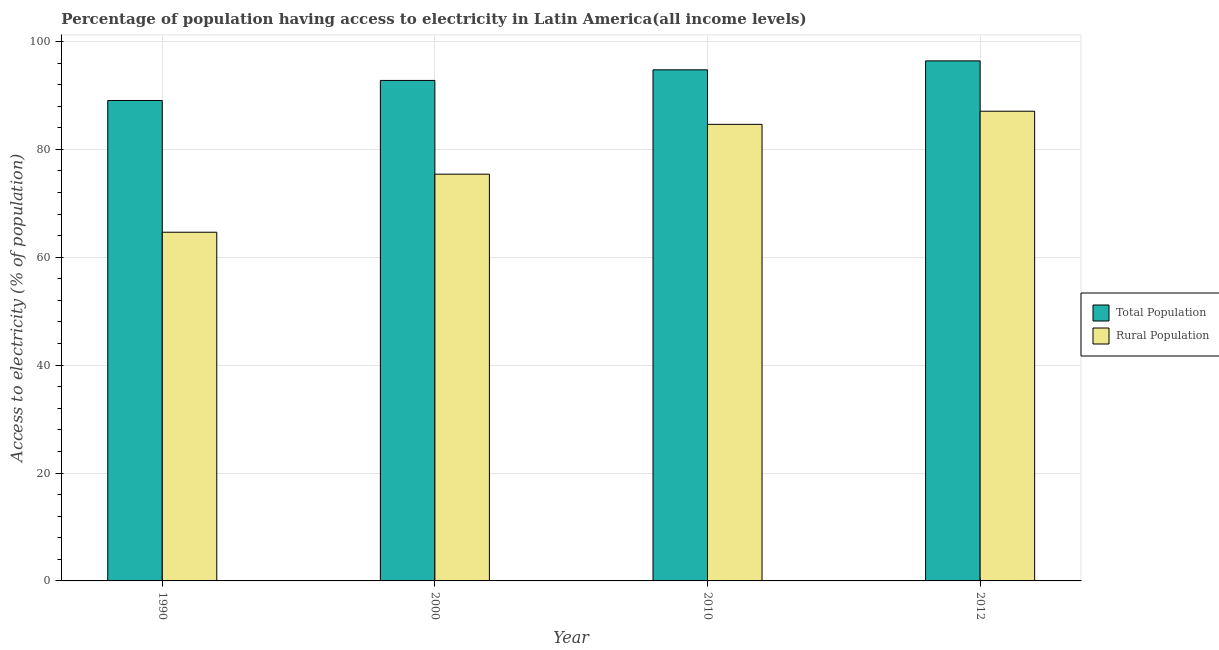How many different coloured bars are there?
Provide a succinct answer. 2. Are the number of bars per tick equal to the number of legend labels?
Give a very brief answer. Yes. How many bars are there on the 4th tick from the right?
Provide a short and direct response. 2. What is the percentage of population having access to electricity in 2000?
Your response must be concise. 92.78. Across all years, what is the maximum percentage of rural population having access to electricity?
Provide a succinct answer. 87.07. Across all years, what is the minimum percentage of population having access to electricity?
Offer a very short reply. 89.06. In which year was the percentage of rural population having access to electricity maximum?
Give a very brief answer. 2012. In which year was the percentage of rural population having access to electricity minimum?
Ensure brevity in your answer.  1990. What is the total percentage of population having access to electricity in the graph?
Your answer should be compact. 373. What is the difference between the percentage of rural population having access to electricity in 2000 and that in 2010?
Give a very brief answer. -9.24. What is the difference between the percentage of rural population having access to electricity in 2012 and the percentage of population having access to electricity in 2010?
Offer a terse response. 2.43. What is the average percentage of rural population having access to electricity per year?
Keep it short and to the point. 77.94. What is the ratio of the percentage of rural population having access to electricity in 2000 to that in 2010?
Your answer should be compact. 0.89. Is the percentage of population having access to electricity in 1990 less than that in 2000?
Offer a very short reply. Yes. Is the difference between the percentage of population having access to electricity in 2000 and 2012 greater than the difference between the percentage of rural population having access to electricity in 2000 and 2012?
Keep it short and to the point. No. What is the difference between the highest and the second highest percentage of rural population having access to electricity?
Offer a very short reply. 2.43. What is the difference between the highest and the lowest percentage of population having access to electricity?
Your answer should be very brief. 7.34. What does the 1st bar from the left in 2010 represents?
Offer a very short reply. Total Population. What does the 1st bar from the right in 2000 represents?
Keep it short and to the point. Rural Population. How many bars are there?
Make the answer very short. 8. Are all the bars in the graph horizontal?
Offer a terse response. No. What is the difference between two consecutive major ticks on the Y-axis?
Provide a succinct answer. 20. Where does the legend appear in the graph?
Offer a very short reply. Center right. How are the legend labels stacked?
Offer a very short reply. Vertical. What is the title of the graph?
Make the answer very short. Percentage of population having access to electricity in Latin America(all income levels). Does "Diesel" appear as one of the legend labels in the graph?
Ensure brevity in your answer.  No. What is the label or title of the Y-axis?
Make the answer very short. Access to electricity (% of population). What is the Access to electricity (% of population) of Total Population in 1990?
Your answer should be very brief. 89.06. What is the Access to electricity (% of population) in Rural Population in 1990?
Offer a very short reply. 64.64. What is the Access to electricity (% of population) of Total Population in 2000?
Offer a terse response. 92.78. What is the Access to electricity (% of population) of Rural Population in 2000?
Your response must be concise. 75.4. What is the Access to electricity (% of population) in Total Population in 2010?
Offer a very short reply. 94.75. What is the Access to electricity (% of population) in Rural Population in 2010?
Ensure brevity in your answer.  84.64. What is the Access to electricity (% of population) in Total Population in 2012?
Your answer should be compact. 96.41. What is the Access to electricity (% of population) of Rural Population in 2012?
Give a very brief answer. 87.07. Across all years, what is the maximum Access to electricity (% of population) in Total Population?
Provide a succinct answer. 96.41. Across all years, what is the maximum Access to electricity (% of population) of Rural Population?
Keep it short and to the point. 87.07. Across all years, what is the minimum Access to electricity (% of population) of Total Population?
Offer a terse response. 89.06. Across all years, what is the minimum Access to electricity (% of population) of Rural Population?
Provide a succinct answer. 64.64. What is the total Access to electricity (% of population) of Total Population in the graph?
Provide a short and direct response. 373. What is the total Access to electricity (% of population) in Rural Population in the graph?
Make the answer very short. 311.76. What is the difference between the Access to electricity (% of population) in Total Population in 1990 and that in 2000?
Provide a succinct answer. -3.72. What is the difference between the Access to electricity (% of population) in Rural Population in 1990 and that in 2000?
Offer a very short reply. -10.76. What is the difference between the Access to electricity (% of population) in Total Population in 1990 and that in 2010?
Provide a short and direct response. -5.68. What is the difference between the Access to electricity (% of population) of Rural Population in 1990 and that in 2010?
Provide a short and direct response. -20. What is the difference between the Access to electricity (% of population) of Total Population in 1990 and that in 2012?
Your answer should be very brief. -7.34. What is the difference between the Access to electricity (% of population) in Rural Population in 1990 and that in 2012?
Your answer should be compact. -22.43. What is the difference between the Access to electricity (% of population) of Total Population in 2000 and that in 2010?
Offer a terse response. -1.96. What is the difference between the Access to electricity (% of population) in Rural Population in 2000 and that in 2010?
Offer a very short reply. -9.24. What is the difference between the Access to electricity (% of population) of Total Population in 2000 and that in 2012?
Offer a terse response. -3.62. What is the difference between the Access to electricity (% of population) of Rural Population in 2000 and that in 2012?
Provide a short and direct response. -11.67. What is the difference between the Access to electricity (% of population) of Total Population in 2010 and that in 2012?
Your answer should be very brief. -1.66. What is the difference between the Access to electricity (% of population) of Rural Population in 2010 and that in 2012?
Your response must be concise. -2.43. What is the difference between the Access to electricity (% of population) in Total Population in 1990 and the Access to electricity (% of population) in Rural Population in 2000?
Offer a very short reply. 13.66. What is the difference between the Access to electricity (% of population) of Total Population in 1990 and the Access to electricity (% of population) of Rural Population in 2010?
Keep it short and to the point. 4.42. What is the difference between the Access to electricity (% of population) of Total Population in 1990 and the Access to electricity (% of population) of Rural Population in 2012?
Provide a short and direct response. 1.99. What is the difference between the Access to electricity (% of population) of Total Population in 2000 and the Access to electricity (% of population) of Rural Population in 2010?
Provide a succinct answer. 8.14. What is the difference between the Access to electricity (% of population) of Total Population in 2000 and the Access to electricity (% of population) of Rural Population in 2012?
Your response must be concise. 5.71. What is the difference between the Access to electricity (% of population) of Total Population in 2010 and the Access to electricity (% of population) of Rural Population in 2012?
Provide a succinct answer. 7.67. What is the average Access to electricity (% of population) in Total Population per year?
Provide a succinct answer. 93.25. What is the average Access to electricity (% of population) in Rural Population per year?
Offer a terse response. 77.94. In the year 1990, what is the difference between the Access to electricity (% of population) of Total Population and Access to electricity (% of population) of Rural Population?
Make the answer very short. 24.42. In the year 2000, what is the difference between the Access to electricity (% of population) of Total Population and Access to electricity (% of population) of Rural Population?
Your response must be concise. 17.38. In the year 2010, what is the difference between the Access to electricity (% of population) in Total Population and Access to electricity (% of population) in Rural Population?
Provide a succinct answer. 10.1. In the year 2012, what is the difference between the Access to electricity (% of population) of Total Population and Access to electricity (% of population) of Rural Population?
Provide a short and direct response. 9.33. What is the ratio of the Access to electricity (% of population) in Total Population in 1990 to that in 2000?
Provide a short and direct response. 0.96. What is the ratio of the Access to electricity (% of population) in Rural Population in 1990 to that in 2000?
Keep it short and to the point. 0.86. What is the ratio of the Access to electricity (% of population) in Rural Population in 1990 to that in 2010?
Your answer should be compact. 0.76. What is the ratio of the Access to electricity (% of population) in Total Population in 1990 to that in 2012?
Your answer should be very brief. 0.92. What is the ratio of the Access to electricity (% of population) in Rural Population in 1990 to that in 2012?
Your answer should be very brief. 0.74. What is the ratio of the Access to electricity (% of population) in Total Population in 2000 to that in 2010?
Offer a very short reply. 0.98. What is the ratio of the Access to electricity (% of population) in Rural Population in 2000 to that in 2010?
Provide a succinct answer. 0.89. What is the ratio of the Access to electricity (% of population) of Total Population in 2000 to that in 2012?
Offer a terse response. 0.96. What is the ratio of the Access to electricity (% of population) in Rural Population in 2000 to that in 2012?
Keep it short and to the point. 0.87. What is the ratio of the Access to electricity (% of population) in Total Population in 2010 to that in 2012?
Your answer should be compact. 0.98. What is the ratio of the Access to electricity (% of population) of Rural Population in 2010 to that in 2012?
Make the answer very short. 0.97. What is the difference between the highest and the second highest Access to electricity (% of population) of Total Population?
Provide a succinct answer. 1.66. What is the difference between the highest and the second highest Access to electricity (% of population) of Rural Population?
Provide a short and direct response. 2.43. What is the difference between the highest and the lowest Access to electricity (% of population) of Total Population?
Provide a succinct answer. 7.34. What is the difference between the highest and the lowest Access to electricity (% of population) of Rural Population?
Ensure brevity in your answer.  22.43. 